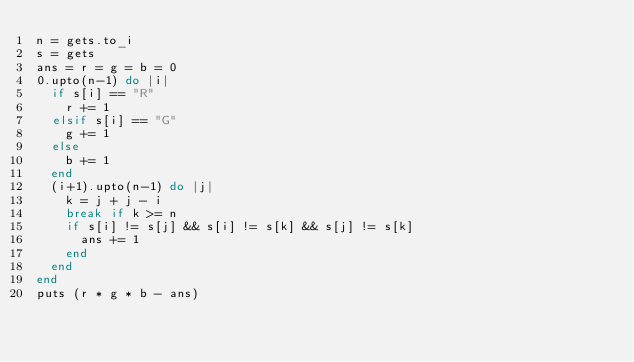Convert code to text. <code><loc_0><loc_0><loc_500><loc_500><_Ruby_>n = gets.to_i
s = gets
ans = r = g = b = 0
0.upto(n-1) do |i|
  if s[i] == "R"
    r += 1
  elsif s[i] == "G"
    g += 1
  else
    b += 1
  end
  (i+1).upto(n-1) do |j|
    k = j + j - i
    break if k >= n
    if s[i] != s[j] && s[i] != s[k] && s[j] != s[k]
      ans += 1
    end
  end
end
puts (r * g * b - ans)</code> 